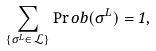<formula> <loc_0><loc_0><loc_500><loc_500>\sum _ { \{ \sigma ^ { L } \in \mathcal { L } \} } \Pr o b ( \sigma ^ { L } ) = 1 ,</formula> 